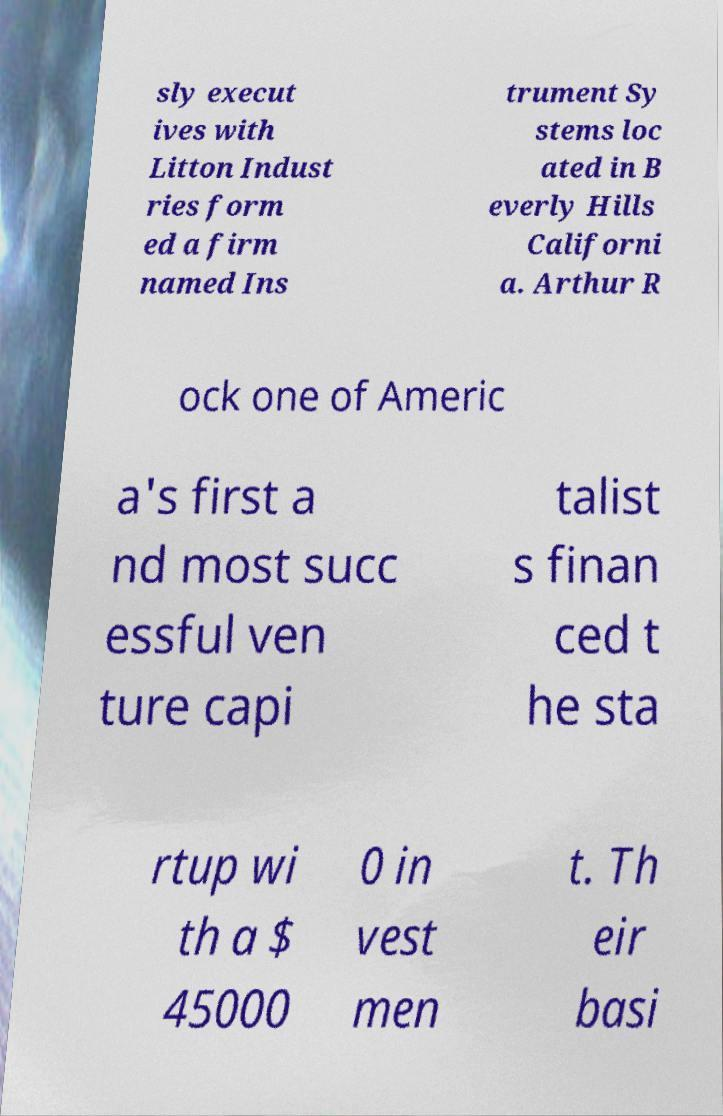Please read and relay the text visible in this image. What does it say? sly execut ives with Litton Indust ries form ed a firm named Ins trument Sy stems loc ated in B everly Hills Californi a. Arthur R ock one of Americ a's first a nd most succ essful ven ture capi talist s finan ced t he sta rtup wi th a $ 45000 0 in vest men t. Th eir basi 